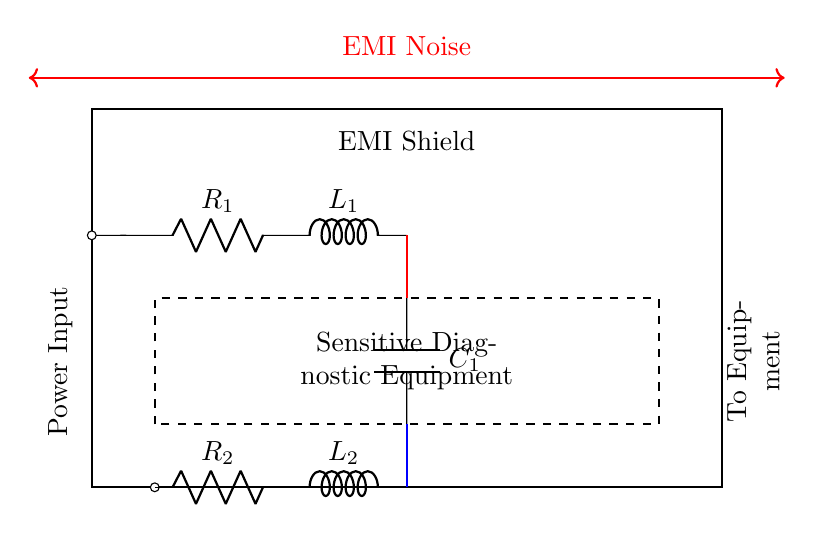What does the rectangle represent in the diagram? The outer rectangle represents the EMI shield, indicated by the label "EMI Shield" at the top. This is designed to protect sensitive equipment inside from electromagnetic interference.
Answer: EMI Shield What is the function of the component labeled R1? R1 is a resistor that limits the current flowing through the circuit. It is placed in series with the power input to regulate the flow of electricity entering the sensitive diagnostic equipment.
Answer: Current limiting What are the components connected to the input power? The input power is connected to a resistor (R1), an inductor (L1), and a capacitor (C1) in series. These components work together to filter and manage the incoming power.
Answer: R1, L1, C1 When considering EMI, why are R2 and L2 connected to ground? R2 and L2 are connected to ground to provide a path for any induced noise currents to safely dissipate into the earth, which protects the sensitive equipment from EMI effects.
Answer: Safety and dissipation What does the red thick line represent in the circuit? The red thick line indicates the connection from the output of the filtering circuit to the sensitive diagnostic equipment. It signifies the pathway for clean power after EMI filtering.
Answer: Connection to equipment What type of circuit is illustrated in the diagram? The circuit is an EMI shielding circuit specifically designed to protect sensitive diagnostic equipment from electromagnetic interference, which is essential for accurate functioning.
Answer: EMI shielding circuit How does the EMI noise affect the circuit? The EMI noise, represented by the red arrows at the top of the diagram, can disrupt the operation of sensitive diagnostic equipment if not properly shielded, potentially leading to faulty readings or equipment failure.
Answer: Disruption of operation 